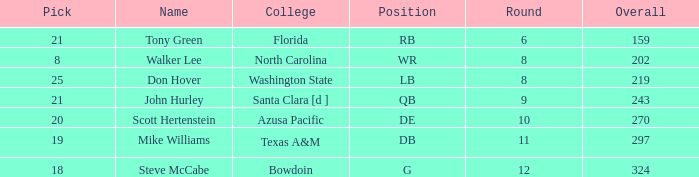Which college has a pick less than 25, an overall greater than 159, a round less than 10, and wr as the position? North Carolina. 